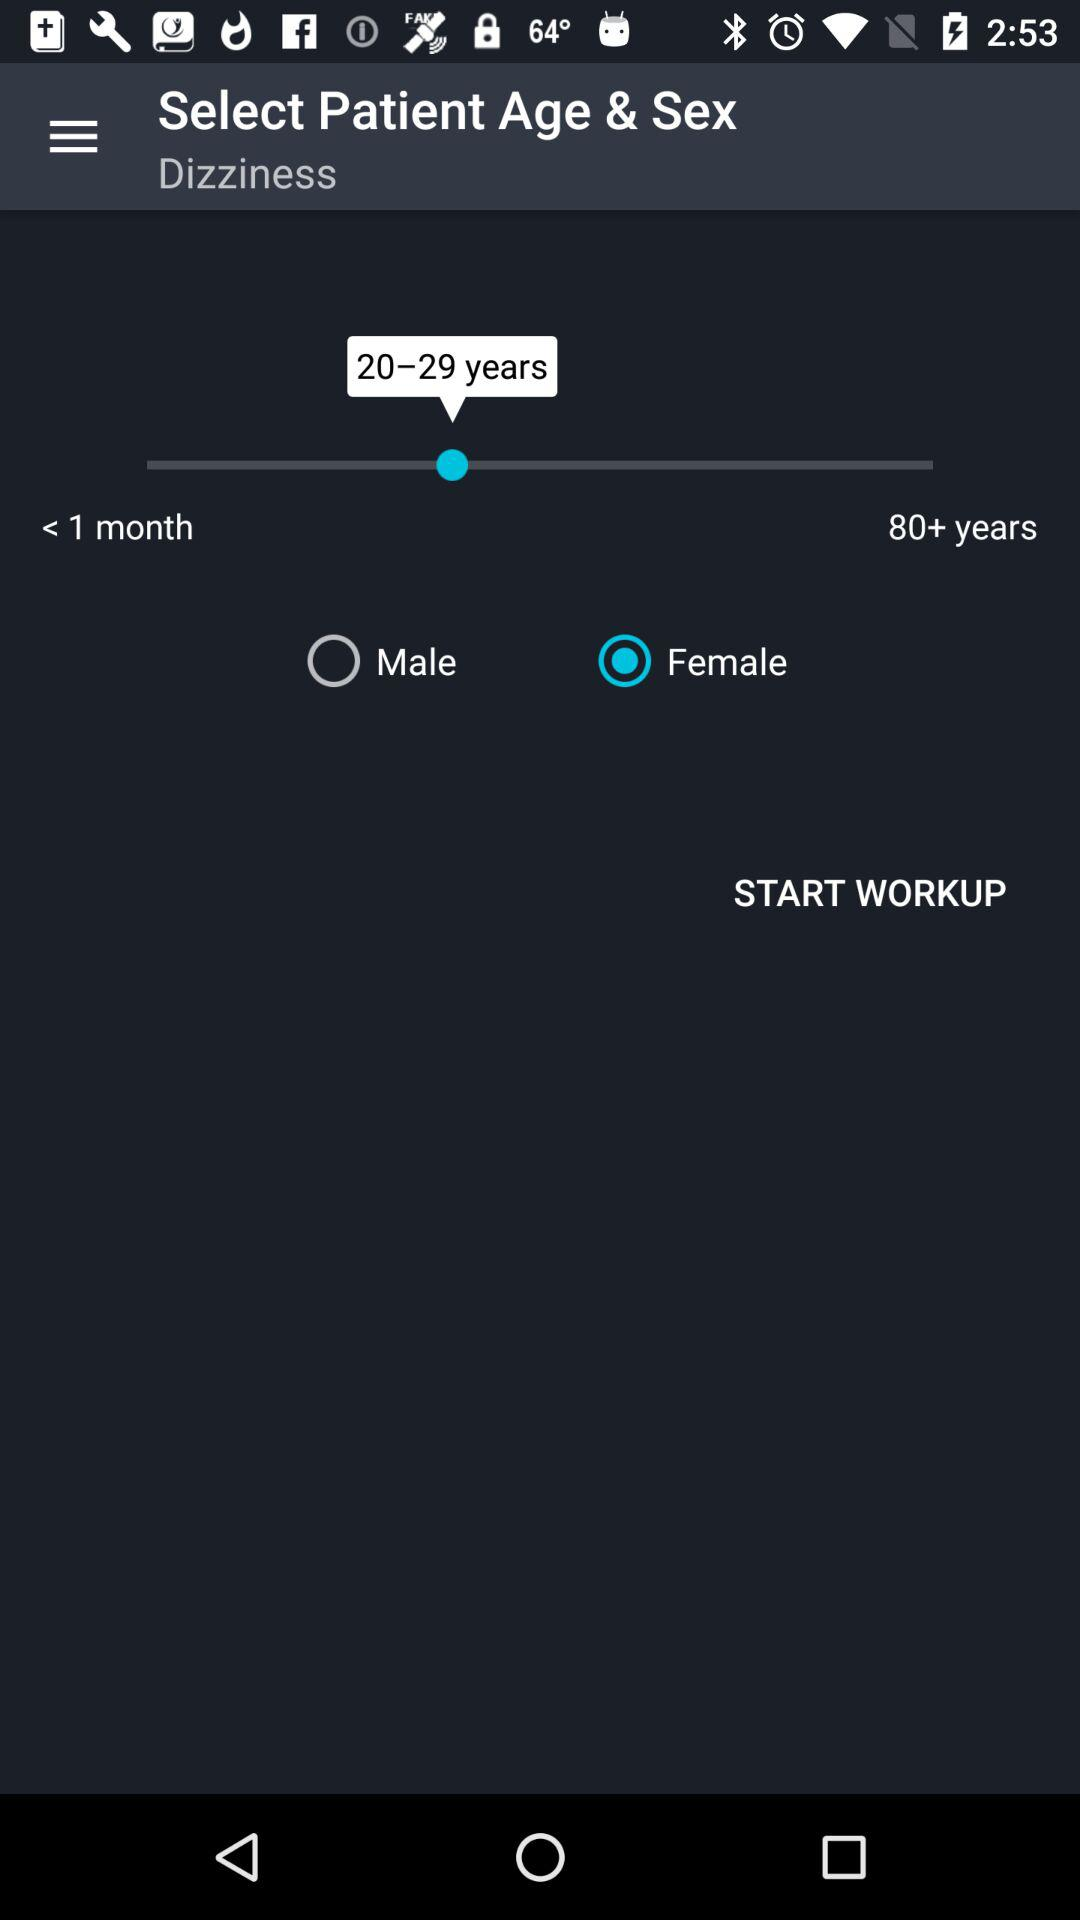What's the gender of the person? The gender of the person is female. 